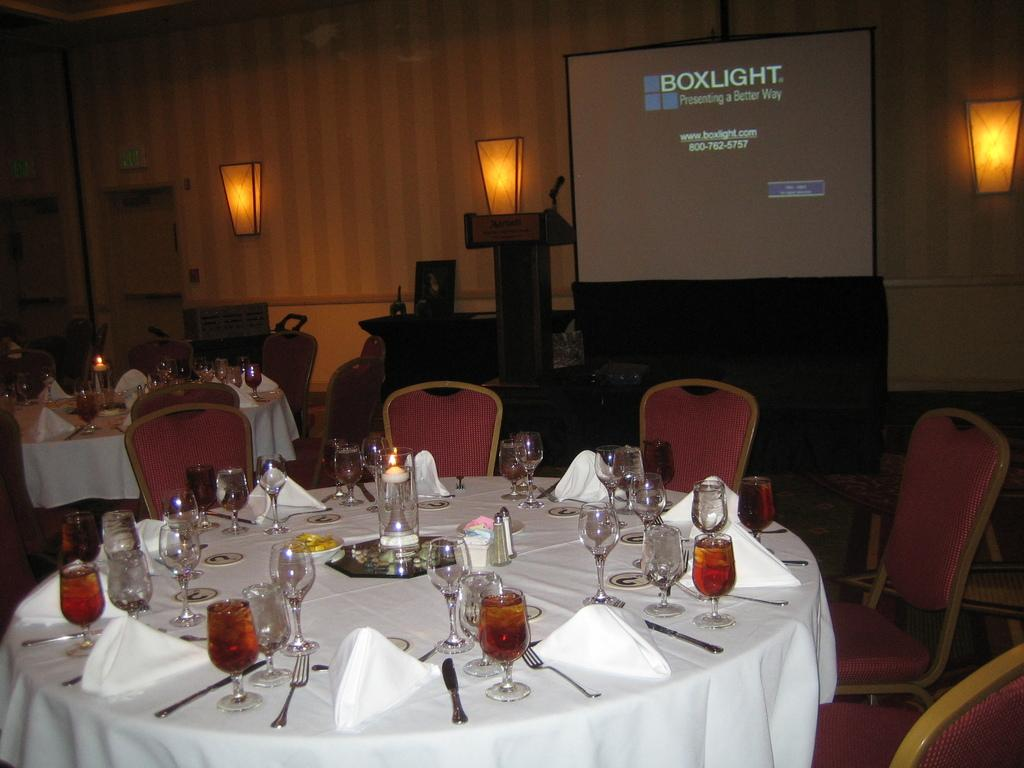<image>
Present a compact description of the photo's key features. A round table sitting in front of a projector that says BoxLight. 